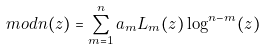Convert formula to latex. <formula><loc_0><loc_0><loc_500><loc_500>\L m o d n ( z ) = \sum _ { m = 1 } ^ { n } a _ { m } L _ { m } ( z ) \log ^ { n - m } ( z )</formula> 